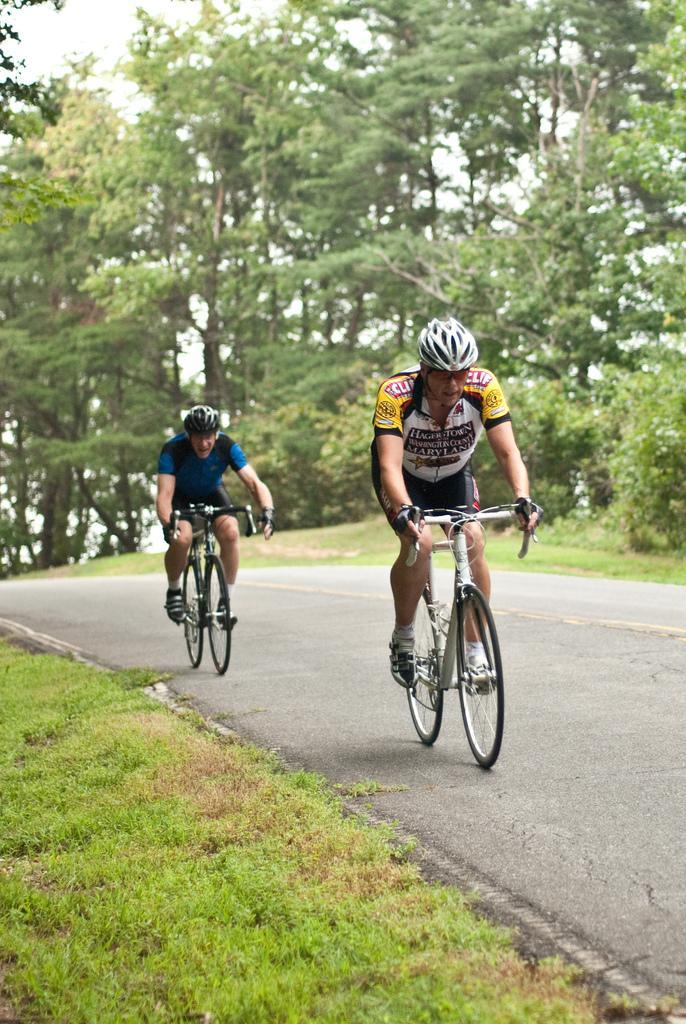Describe this image in one or two sentences. Here I can see two men wearing t-shirts, shorts, helmets on the heads and riding the bicycles on the road. On both sides of the road I can see the grass. In the background there are many trees. 